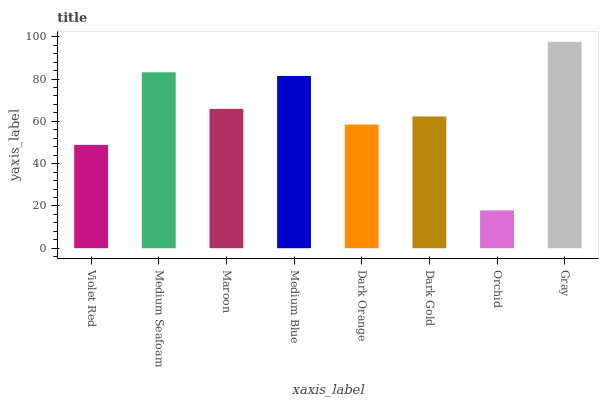Is Orchid the minimum?
Answer yes or no. Yes. Is Gray the maximum?
Answer yes or no. Yes. Is Medium Seafoam the minimum?
Answer yes or no. No. Is Medium Seafoam the maximum?
Answer yes or no. No. Is Medium Seafoam greater than Violet Red?
Answer yes or no. Yes. Is Violet Red less than Medium Seafoam?
Answer yes or no. Yes. Is Violet Red greater than Medium Seafoam?
Answer yes or no. No. Is Medium Seafoam less than Violet Red?
Answer yes or no. No. Is Maroon the high median?
Answer yes or no. Yes. Is Dark Gold the low median?
Answer yes or no. Yes. Is Medium Blue the high median?
Answer yes or no. No. Is Medium Seafoam the low median?
Answer yes or no. No. 